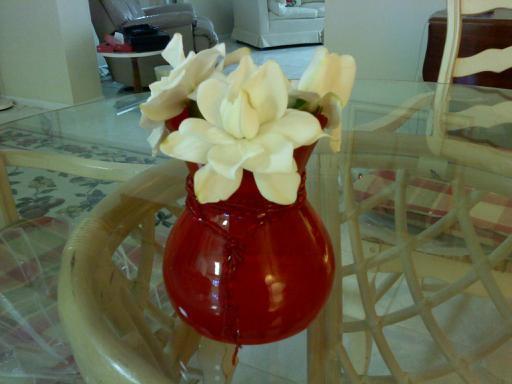How many colors are on the vase?
Short answer required. 1. Could this table use buffing?
Give a very brief answer. No. Is there water in the vase?
Short answer required. Yes. Is the table clear?
Short answer required. Yes. What in the picture is not a fruit or vegetable?
Quick response, please. Flowers. Are these fake flowers?
Write a very short answer. No. What shape is this table?
Write a very short answer. Round. Is there anything edible?
Answer briefly. No. 